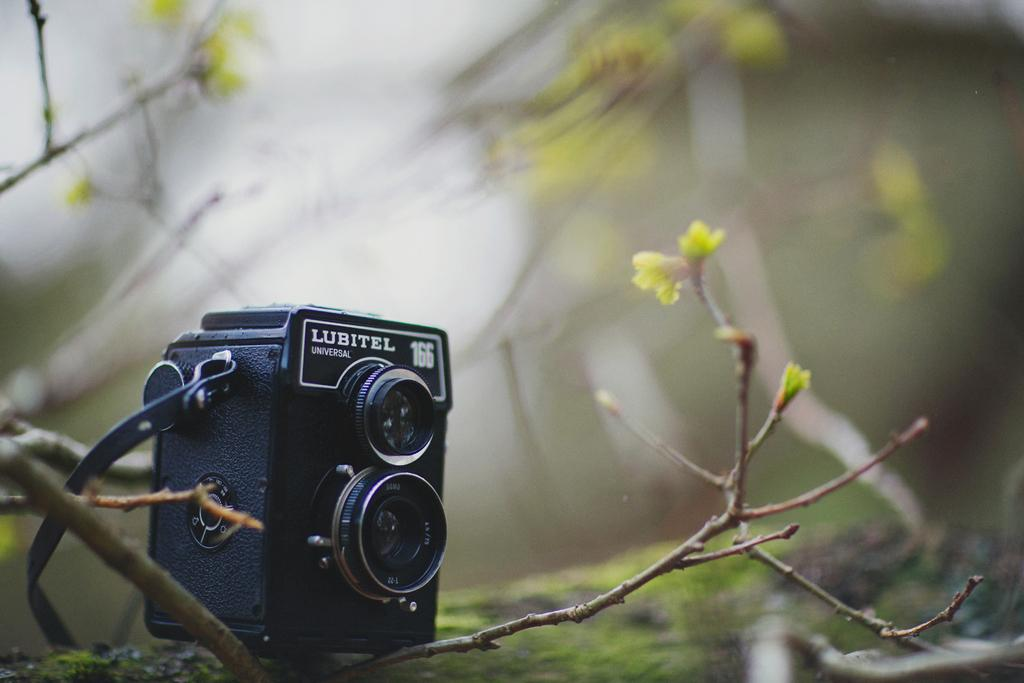What object is the main subject of the image? There is a black color camera in the image. Where is the camera positioned in the image? The camera is placed on a tree branch. Can you describe the background of the image? The background in the image is blurred. How many houses can be seen in the background of the image? There are no houses visible in the image. What type of grass is growing on the tree branch where the camera is placed? There is no grass present in the image. 